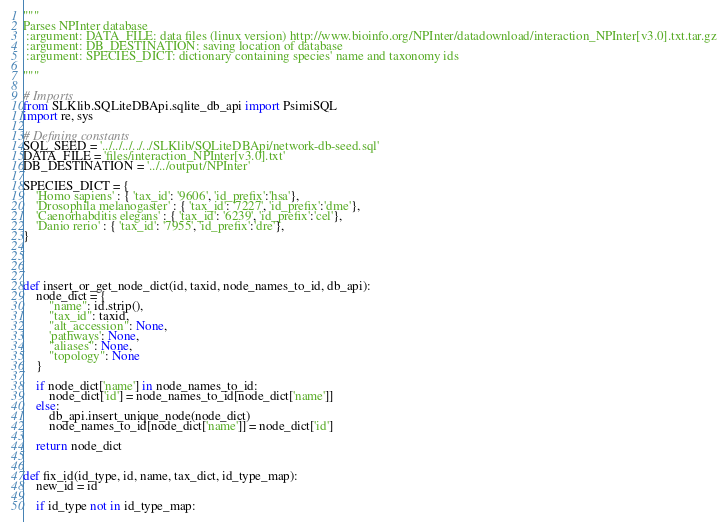<code> <loc_0><loc_0><loc_500><loc_500><_Python_>"""
Parses NPInter database
 :argument: DATA_FILE: data files (linux version) http://www.bioinfo.org/NPInter/datadownload/interaction_NPInter[v3.0].txt.tar.gz
 :argument: DB_DESTINATION: saving location of database
 :argument: SPECIES_DICT: dictionary containing species' name and taxonomy ids

"""

# Imports
from SLKlib.SQLiteDBApi.sqlite_db_api import PsimiSQL
import re, sys

# Defining constants
SQL_SEED = '../../../../../SLKlib/SQLiteDBApi/network-db-seed.sql'
DATA_FILE = 'files/interaction_NPInter[v3.0].txt'
DB_DESTINATION = '../../output/NPInter'

SPECIES_DICT = {
    'Homo sapiens' : { 'tax_id': '9606', 'id_prefix':'hsa'},
    'Drosophila melanogaster' : { 'tax_id': '7227', 'id_prefix':'dme'},
    'Caenorhabditis elegans' : { 'tax_id': '6239', 'id_prefix':'cel'},
    'Danio rerio' : { 'tax_id': '7955', 'id_prefix':'dre'},
}




def insert_or_get_node_dict(id, taxid, node_names_to_id, db_api):
    node_dict = {
        "name": id.strip(),
        "tax_id": taxid,
        "alt_accession": None,
        'pathways': None,
        "aliases": None,
        "topology": None
    }

    if node_dict['name'] in node_names_to_id:
        node_dict['id'] = node_names_to_id[node_dict['name']]
    else:
        db_api.insert_unique_node(node_dict)
        node_names_to_id[node_dict['name']] = node_dict['id']

    return node_dict


def fix_id(id_type, id, name, tax_dict, id_type_map):
    new_id = id

    if id_type not in id_type_map:</code> 